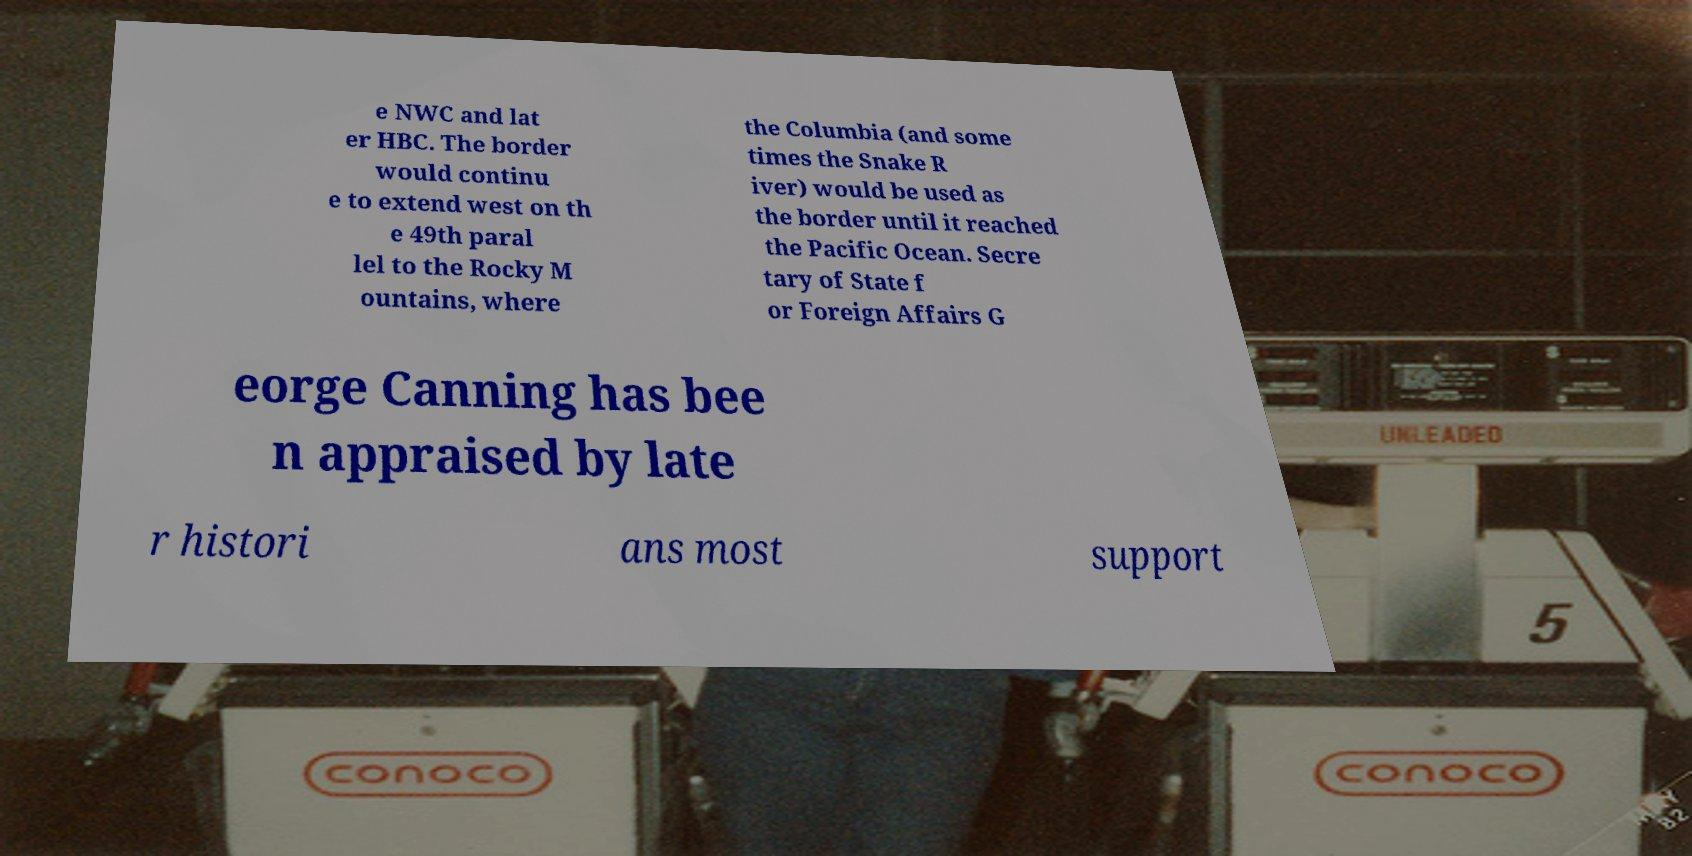What messages or text are displayed in this image? I need them in a readable, typed format. e NWC and lat er HBC. The border would continu e to extend west on th e 49th paral lel to the Rocky M ountains, where the Columbia (and some times the Snake R iver) would be used as the border until it reached the Pacific Ocean. Secre tary of State f or Foreign Affairs G eorge Canning has bee n appraised by late r histori ans most support 